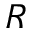Convert formula to latex. <formula><loc_0><loc_0><loc_500><loc_500>R</formula> 